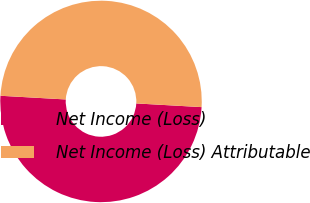<chart> <loc_0><loc_0><loc_500><loc_500><pie_chart><fcel>Net Income (Loss)<fcel>Net Income (Loss) Attributable<nl><fcel>50.0%<fcel>50.0%<nl></chart> 